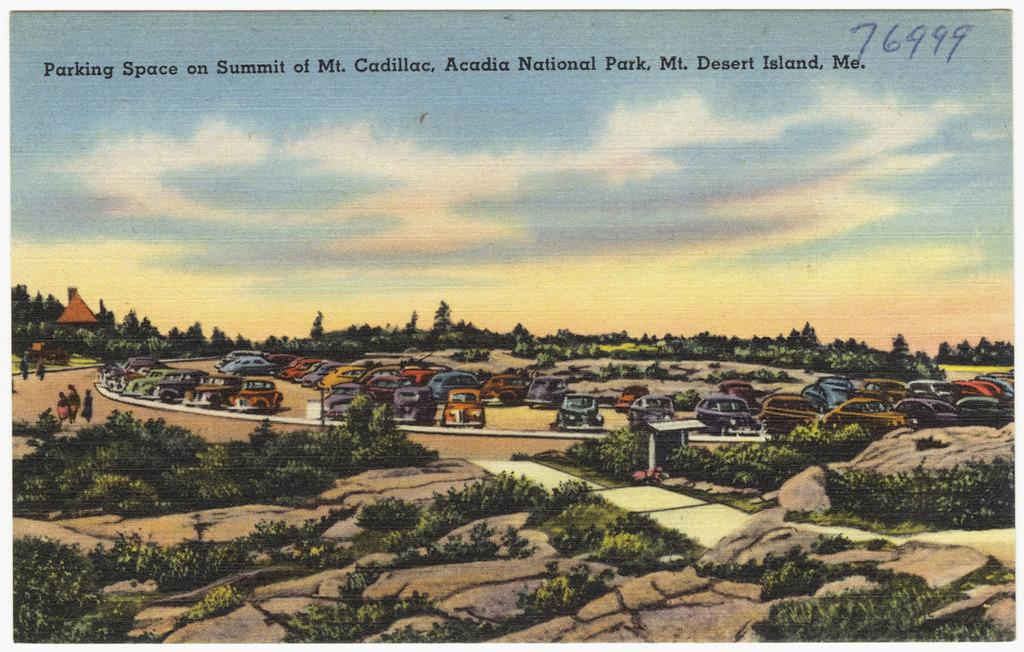<image>
Give a short and clear explanation of the subsequent image. A poster showing a parking space on the summit of Mt. Cadillac. 